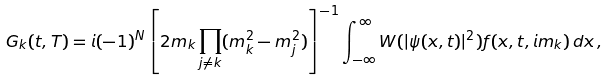<formula> <loc_0><loc_0><loc_500><loc_500>G _ { k } ( t , T ) = i ( - 1 ) ^ { N } \left [ 2 m _ { k } \prod _ { j \neq k } ( m _ { k } ^ { 2 } - m _ { j } ^ { 2 } ) \right ] ^ { - 1 } \int _ { - \infty } ^ { \infty } W ( | \psi ( x , t ) | ^ { 2 } ) f ( x , t , i m _ { k } ) \, d x \, ,</formula> 